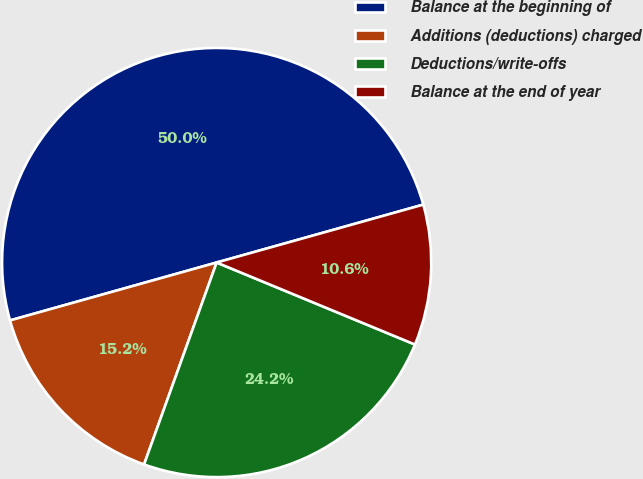Convert chart to OTSL. <chart><loc_0><loc_0><loc_500><loc_500><pie_chart><fcel>Balance at the beginning of<fcel>Additions (deductions) charged<fcel>Deductions/write-offs<fcel>Balance at the end of year<nl><fcel>50.0%<fcel>15.16%<fcel>24.25%<fcel>10.59%<nl></chart> 